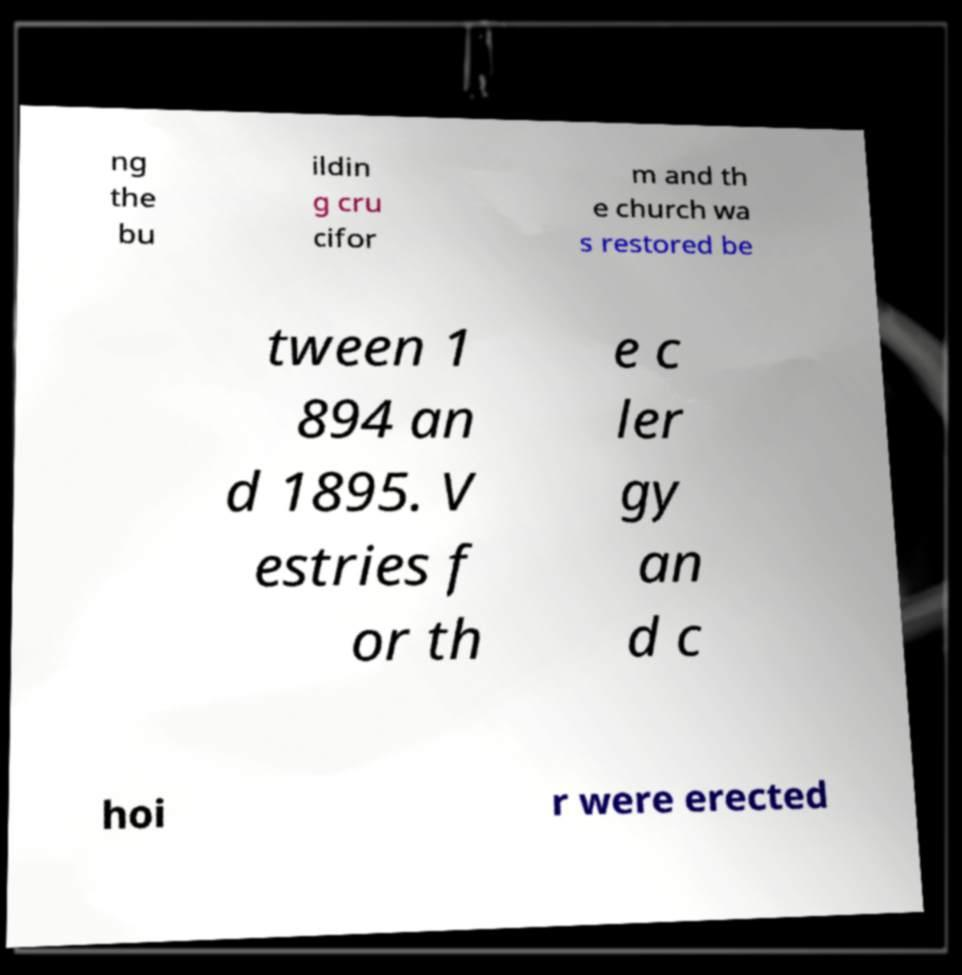There's text embedded in this image that I need extracted. Can you transcribe it verbatim? ng the bu ildin g cru cifor m and th e church wa s restored be tween 1 894 an d 1895. V estries f or th e c ler gy an d c hoi r were erected 